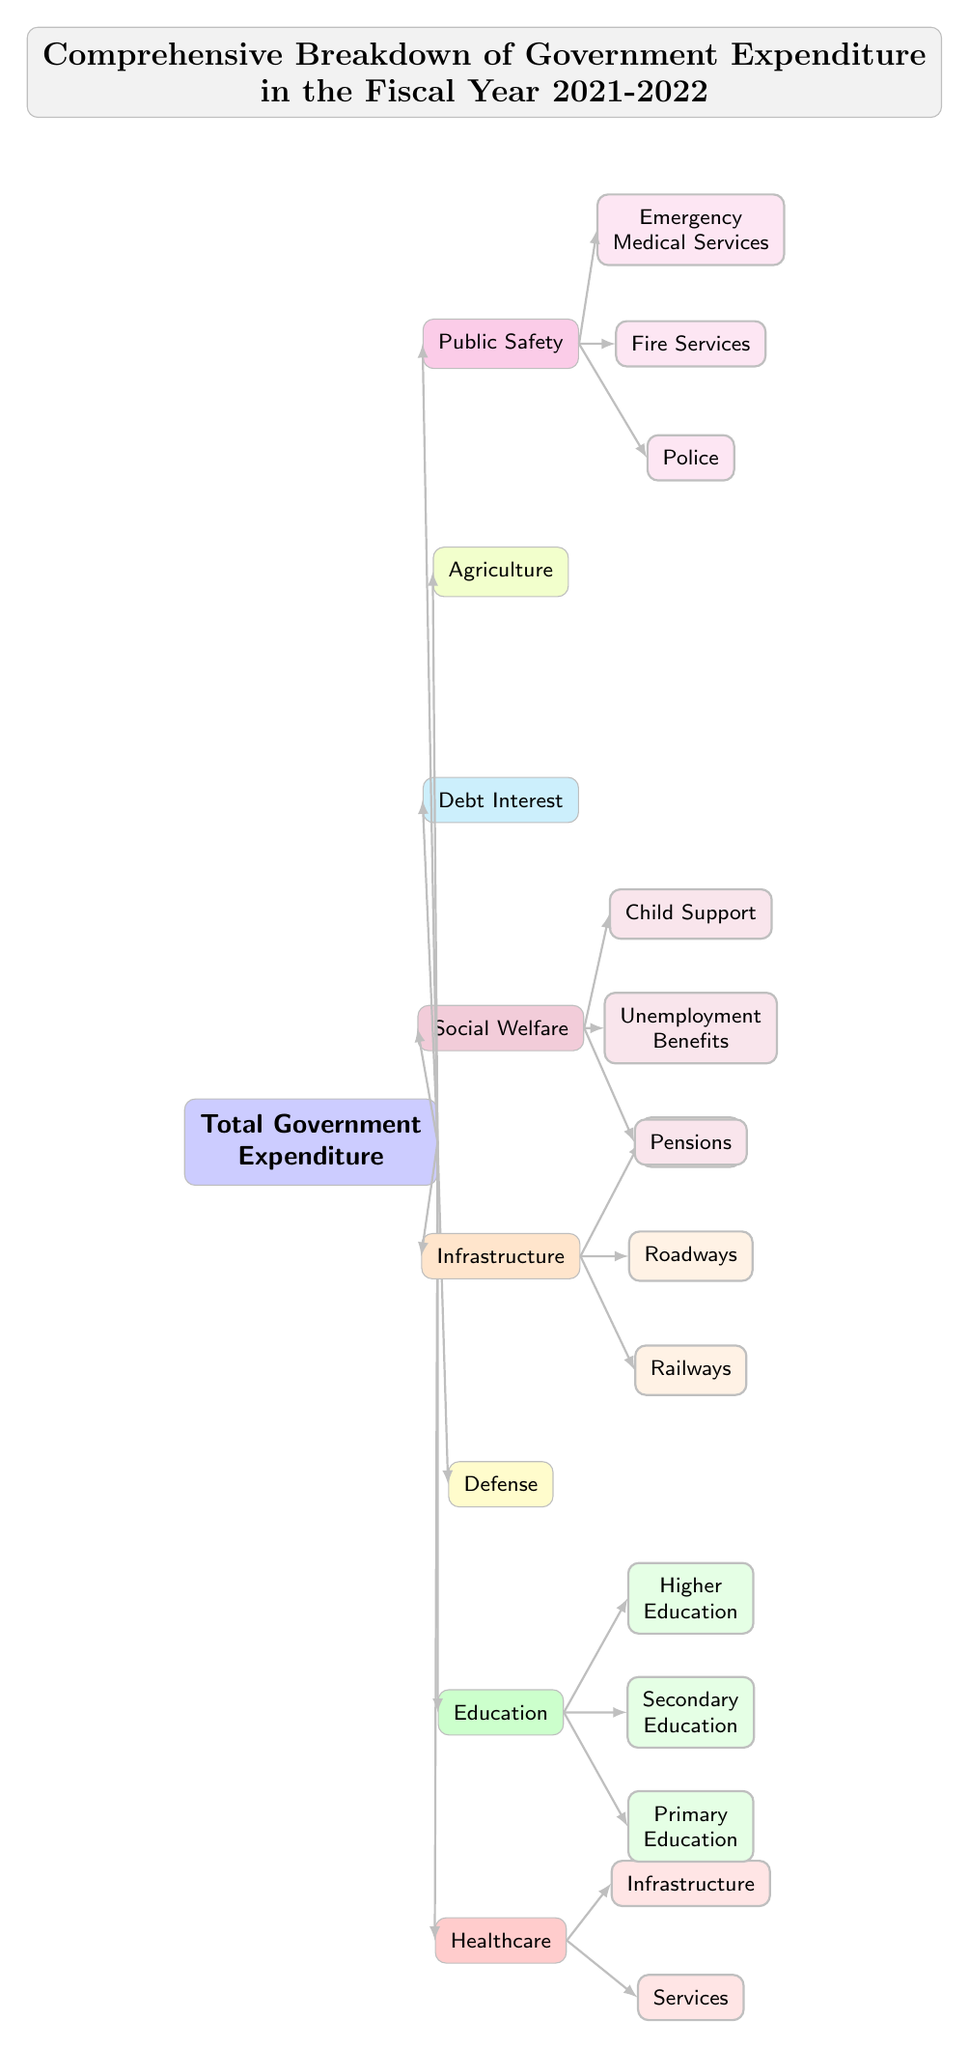What is the total number of expenditure categories? There are eight categories listed in the diagram: Healthcare, Education, Defense, Infrastructure, Social Welfare, Debt Interest, Agriculture, and Public Safety.
Answer: 8 Which department is responsible for Pensions? The subcategory Pensions falls under the main category of Social Welfare, as shown in the diagram.
Answer: Social Welfare What are the three main types of expenditure under Infrastructure? The diagram lists three subcategories under Infrastructure: Railways, Roadways, and Bridges, which are all part of the Infrastructure department.
Answer: Railways, Roadways, Bridges Which department includes Emergency Medical Services? Emergency Medical Services is found under the Public Safety category of the government expenditure diagram, specifically as a subcategory.
Answer: Public Safety Is Healthcare divided into subcategories? Yes, Healthcare has two subcategories: Services and Infrastructure, which are branches under the Healthcare node.
Answer: Yes How many types of education are detailed in the diagram? The diagram identifies three types of education: Primary Education, Secondary Education, and Higher Education, which are all listed as subcategories under Education.
Answer: 3 What is the color used for the Education category? The Education category is represented in green, specifically a darker shade for the main node and lighter shades for the subcategories.
Answer: Green Which categories are shown in the highest prominence level? The diagram's main categories at the top level, also referred to as the highest prominence level, include Healthcare, Education, Defense, Infrastructure, Social Welfare, Debt Interest, Agriculture, and Public Safety.
Answer: 8 Categories What is the overall title of the diagram? The complete title as depicted in the diagram is "Comprehensive Breakdown of Government Expenditure in the Fiscal Year 2021-2022."
Answer: Comprehensive Breakdown of Government Expenditure in the Fiscal Year 2021-2022 